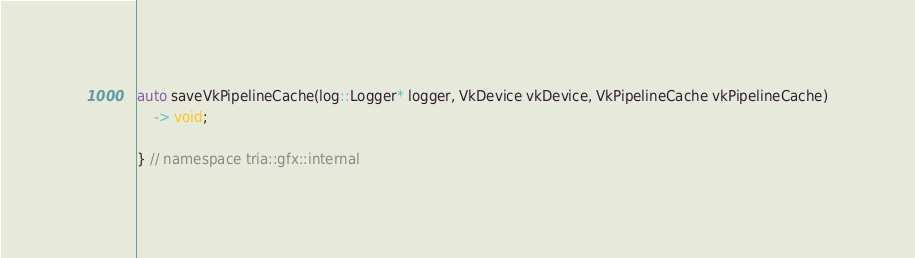Convert code to text. <code><loc_0><loc_0><loc_500><loc_500><_C++_>auto saveVkPipelineCache(log::Logger* logger, VkDevice vkDevice, VkPipelineCache vkPipelineCache)
    -> void;

} // namespace tria::gfx::internal
</code> 